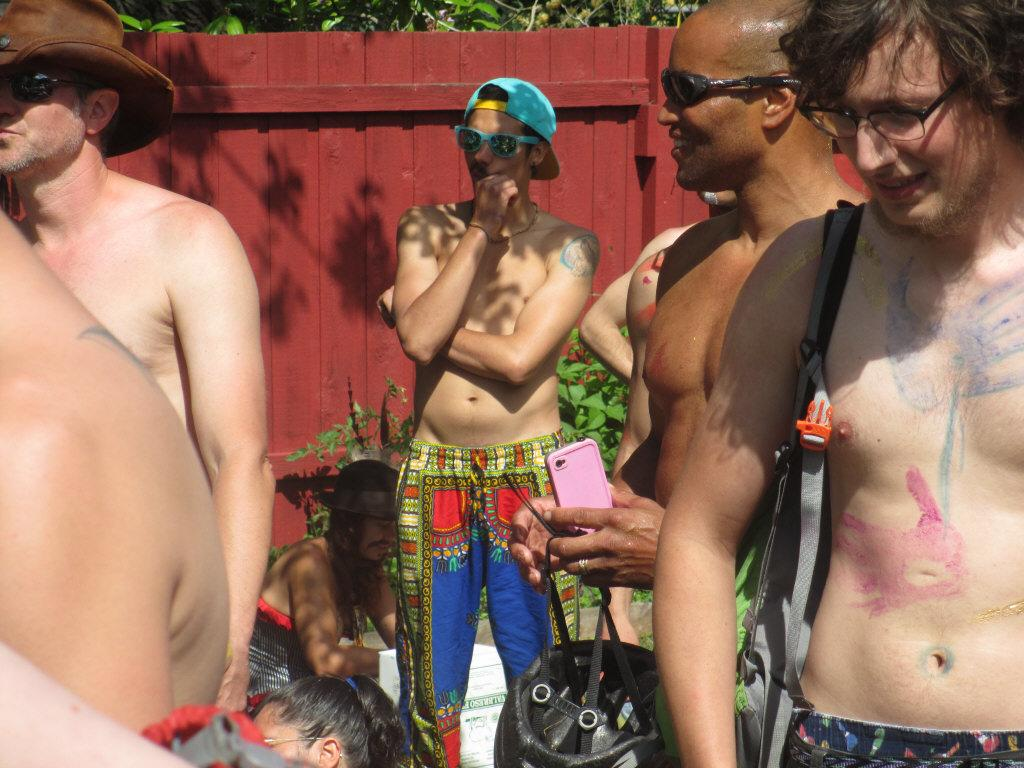How many men are in the image? There are many men in the image. What are the men wearing in the image? The men are not wearing shirts, but they are wearing glasses. What can be seen in the background of the image? There is land visible in the image, as well as a wooden fence. What type of vegetation is present near the wooden fence? Plants are present on either side of the wooden fence. What letter is the minister holding in the image? There is no minister or letter present in the image. Can you see any yaks in the image? There are no yaks present in the image. 